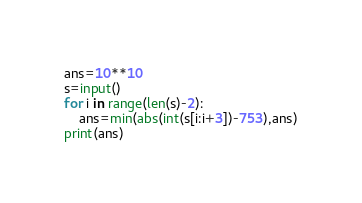<code> <loc_0><loc_0><loc_500><loc_500><_Python_>ans=10**10
s=input()
for i in range(len(s)-2):
    ans=min(abs(int(s[i:i+3])-753),ans)
print(ans)</code> 